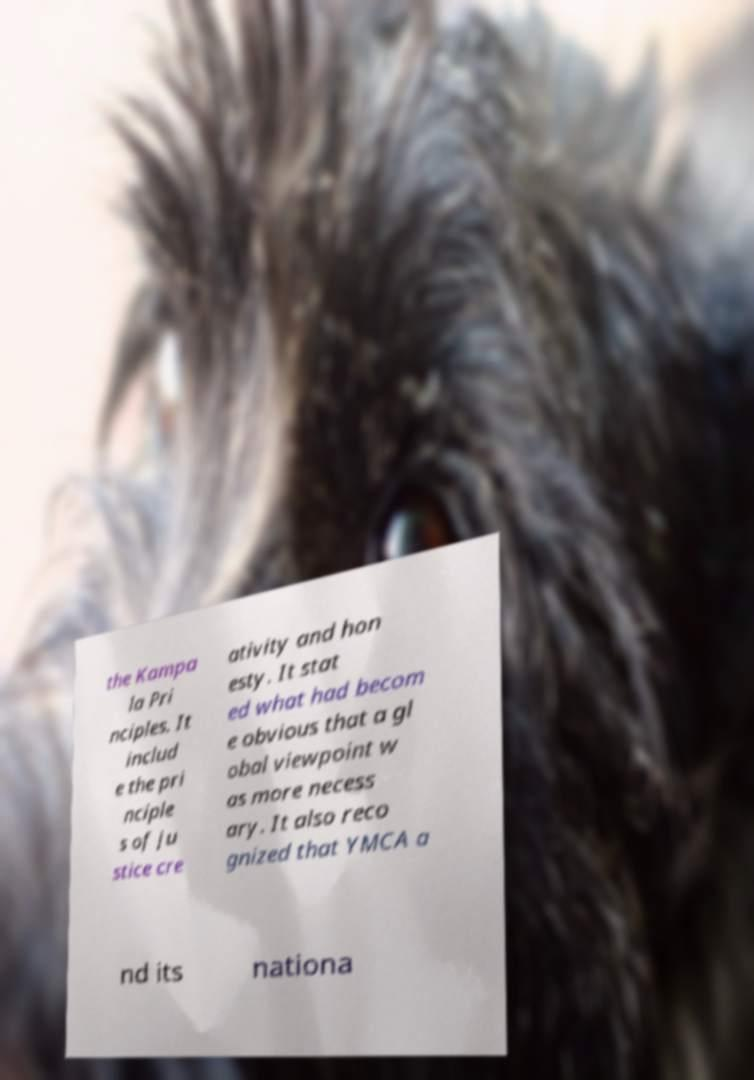Can you read and provide the text displayed in the image?This photo seems to have some interesting text. Can you extract and type it out for me? the Kampa la Pri nciples. It includ e the pri nciple s of ju stice cre ativity and hon esty. It stat ed what had becom e obvious that a gl obal viewpoint w as more necess ary. It also reco gnized that YMCA a nd its nationa 